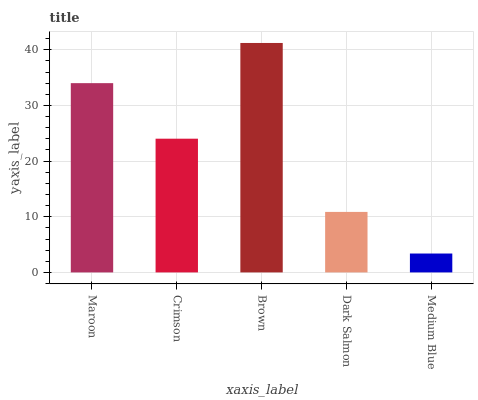Is Medium Blue the minimum?
Answer yes or no. Yes. Is Brown the maximum?
Answer yes or no. Yes. Is Crimson the minimum?
Answer yes or no. No. Is Crimson the maximum?
Answer yes or no. No. Is Maroon greater than Crimson?
Answer yes or no. Yes. Is Crimson less than Maroon?
Answer yes or no. Yes. Is Crimson greater than Maroon?
Answer yes or no. No. Is Maroon less than Crimson?
Answer yes or no. No. Is Crimson the high median?
Answer yes or no. Yes. Is Crimson the low median?
Answer yes or no. Yes. Is Dark Salmon the high median?
Answer yes or no. No. Is Dark Salmon the low median?
Answer yes or no. No. 